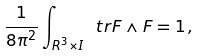<formula> <loc_0><loc_0><loc_500><loc_500>\frac { 1 } { 8 \pi ^ { 2 } } \int _ { R ^ { 3 } \times I } \ t r F \wedge F = 1 \, ,</formula> 